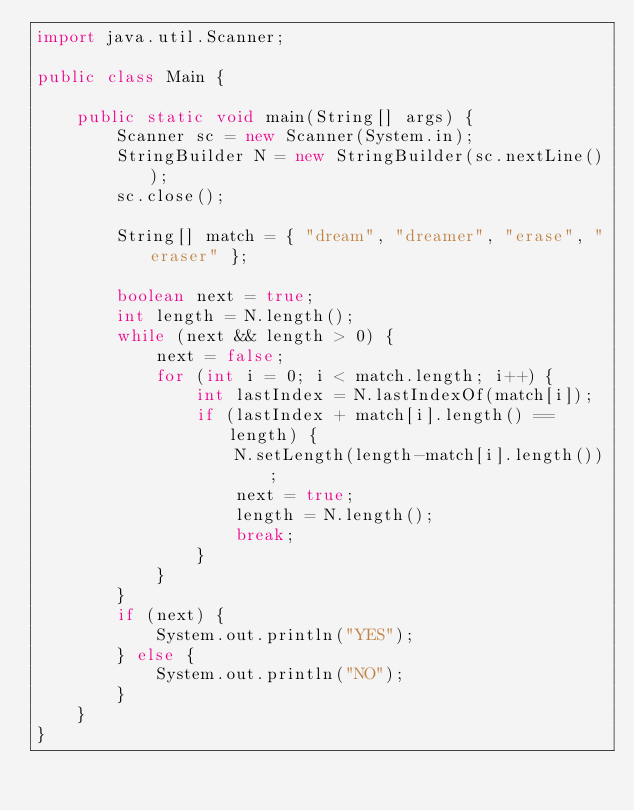<code> <loc_0><loc_0><loc_500><loc_500><_Java_>import java.util.Scanner;

public class Main {

    public static void main(String[] args) {
        Scanner sc = new Scanner(System.in);
        StringBuilder N = new StringBuilder(sc.nextLine());
        sc.close();

        String[] match = { "dream", "dreamer", "erase", "eraser" };

        boolean next = true;
        int length = N.length();
        while (next && length > 0) {
            next = false;
            for (int i = 0; i < match.length; i++) {
                int lastIndex = N.lastIndexOf(match[i]);
                if (lastIndex + match[i].length() == length) {
                    N.setLength(length-match[i].length());
                    next = true;
                    length = N.length();
                    break;
                }
            }
        }
        if (next) {
            System.out.println("YES");
        } else {
            System.out.println("NO");
        }
    }
}</code> 